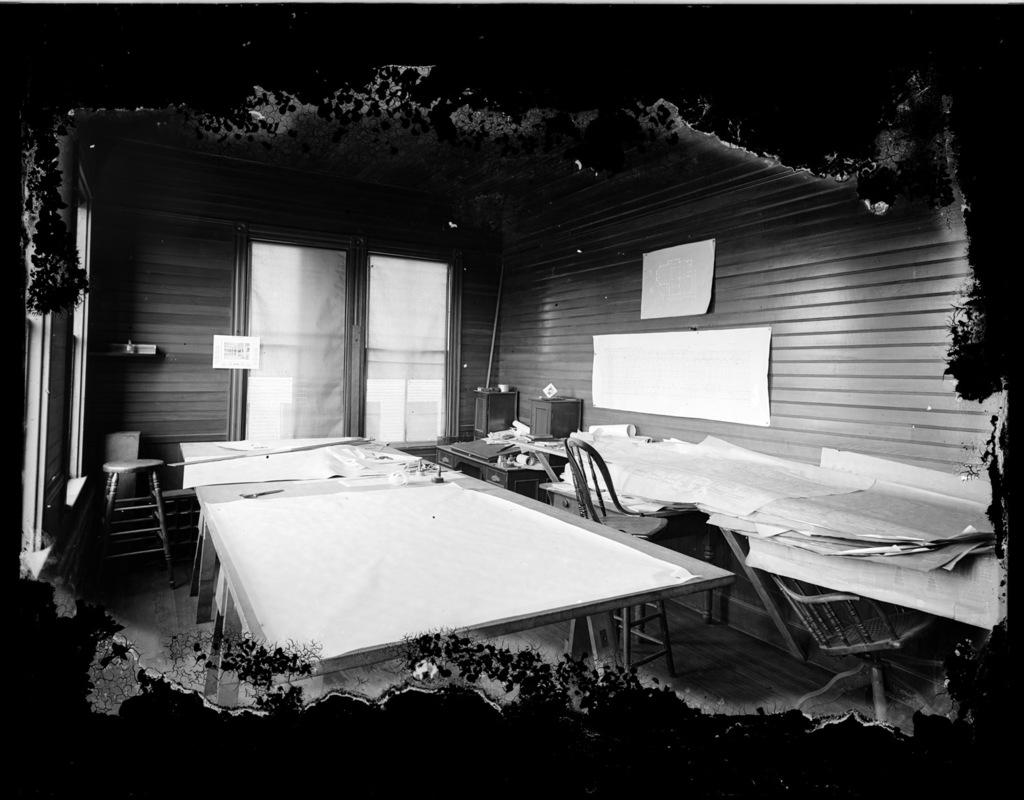What type of space is shown in the image? The image depicts an inside view of a room. What furniture can be seen in the room? There are chairs in the room. What items are on the tables in the room? There are papers on the tables in the room. What decorations are on the wall in the background? There are posters on the wall in the background. What direction is the room facing in the image? The direction the room is facing cannot be determined from the image, as it only shows an inside view. What type of food is being served on the tables in the image? There is no food visible on the tables in the image; only papers can be seen. 